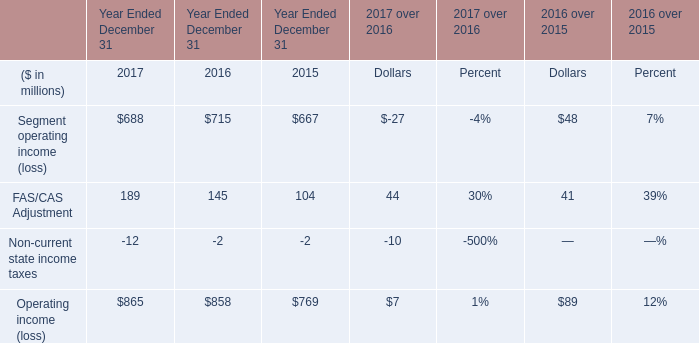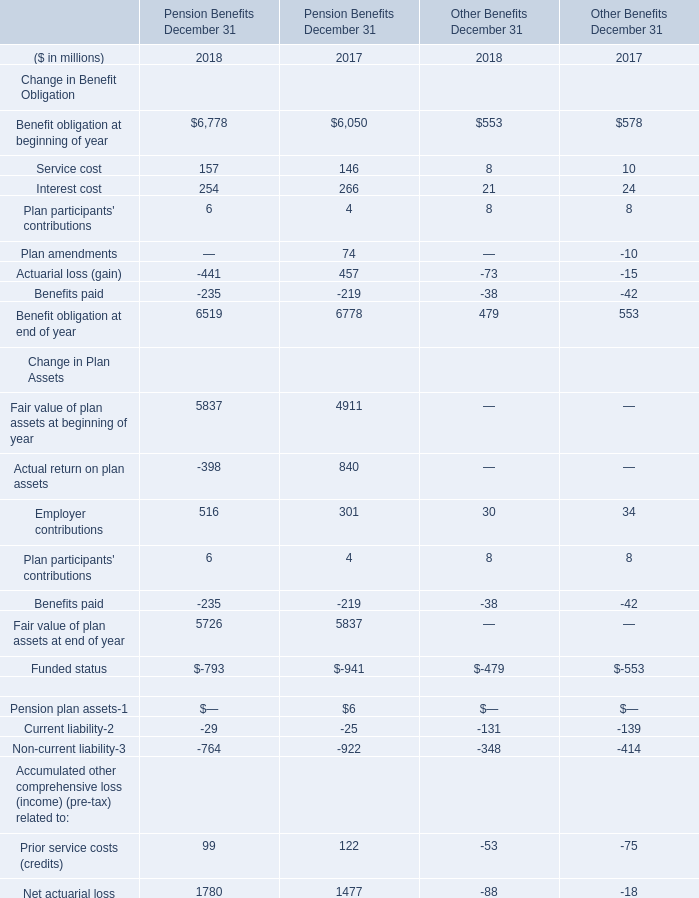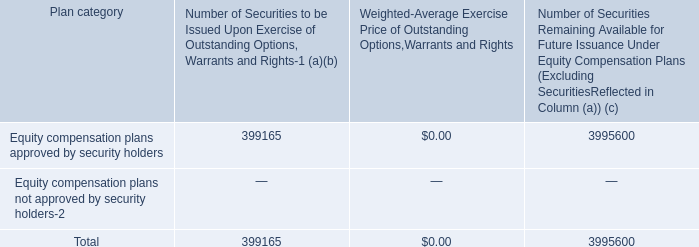What is the average value of Actuarial loss (gain) of Pension Benefits December 31 in Table 1 and FAS/CAS Adjustment in Table 0 in 2017? (in million) 
Computations: ((457 + 189) / 2)
Answer: 323.0. 